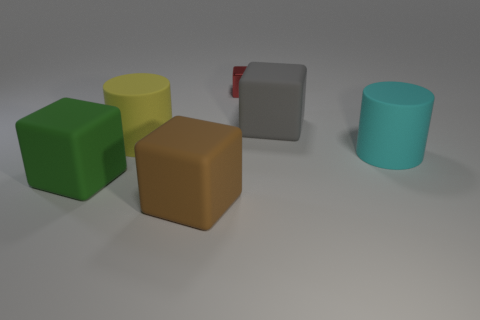Subtract 1 blocks. How many blocks are left? 3 Add 4 big cyan cylinders. How many objects exist? 10 Subtract all blocks. How many objects are left? 2 Add 2 metal cubes. How many metal cubes exist? 3 Subtract 0 blue cubes. How many objects are left? 6 Subtract all rubber objects. Subtract all tiny objects. How many objects are left? 0 Add 1 red objects. How many red objects are left? 2 